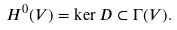Convert formula to latex. <formula><loc_0><loc_0><loc_500><loc_500>H ^ { 0 } ( V ) = \ker D \subset \Gamma ( V ) .</formula> 